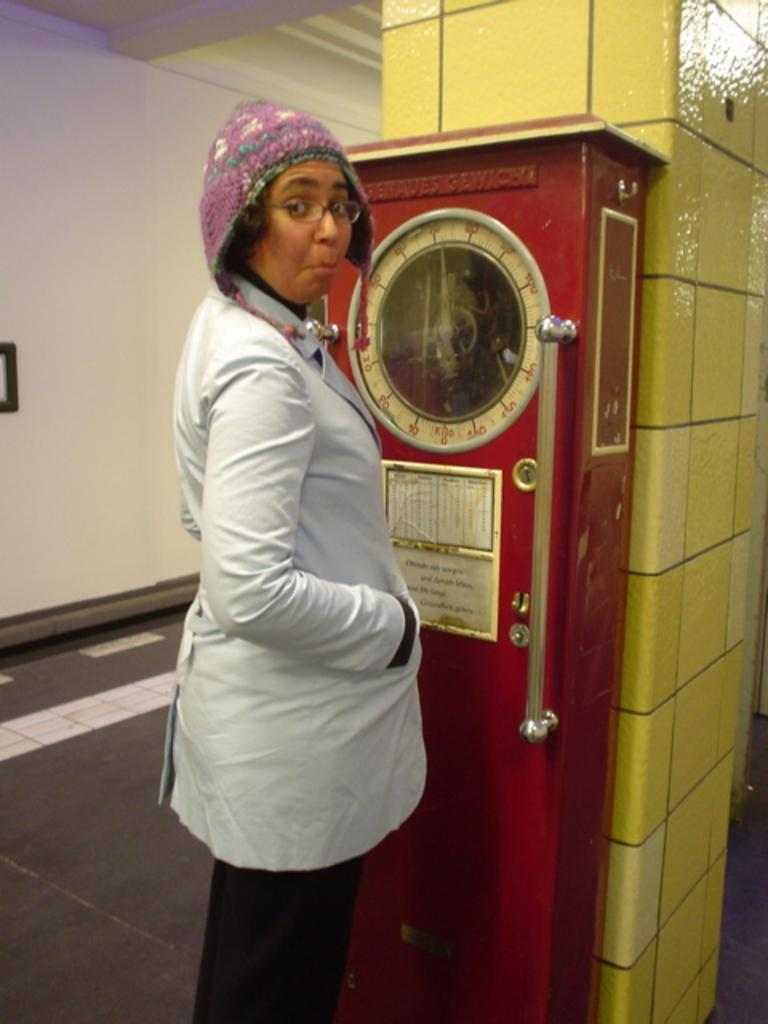Who is the main subject in the image? There is a woman in the image. What is the woman doing in the image? The woman is standing on a weighing machine. Is the woman interacting with anyone or anything in the image? The woman is looking at someone. What type of cave can be seen in the background of the image? There is no cave present in the image; it features a woman standing on a weighing machine and looking at someone. 